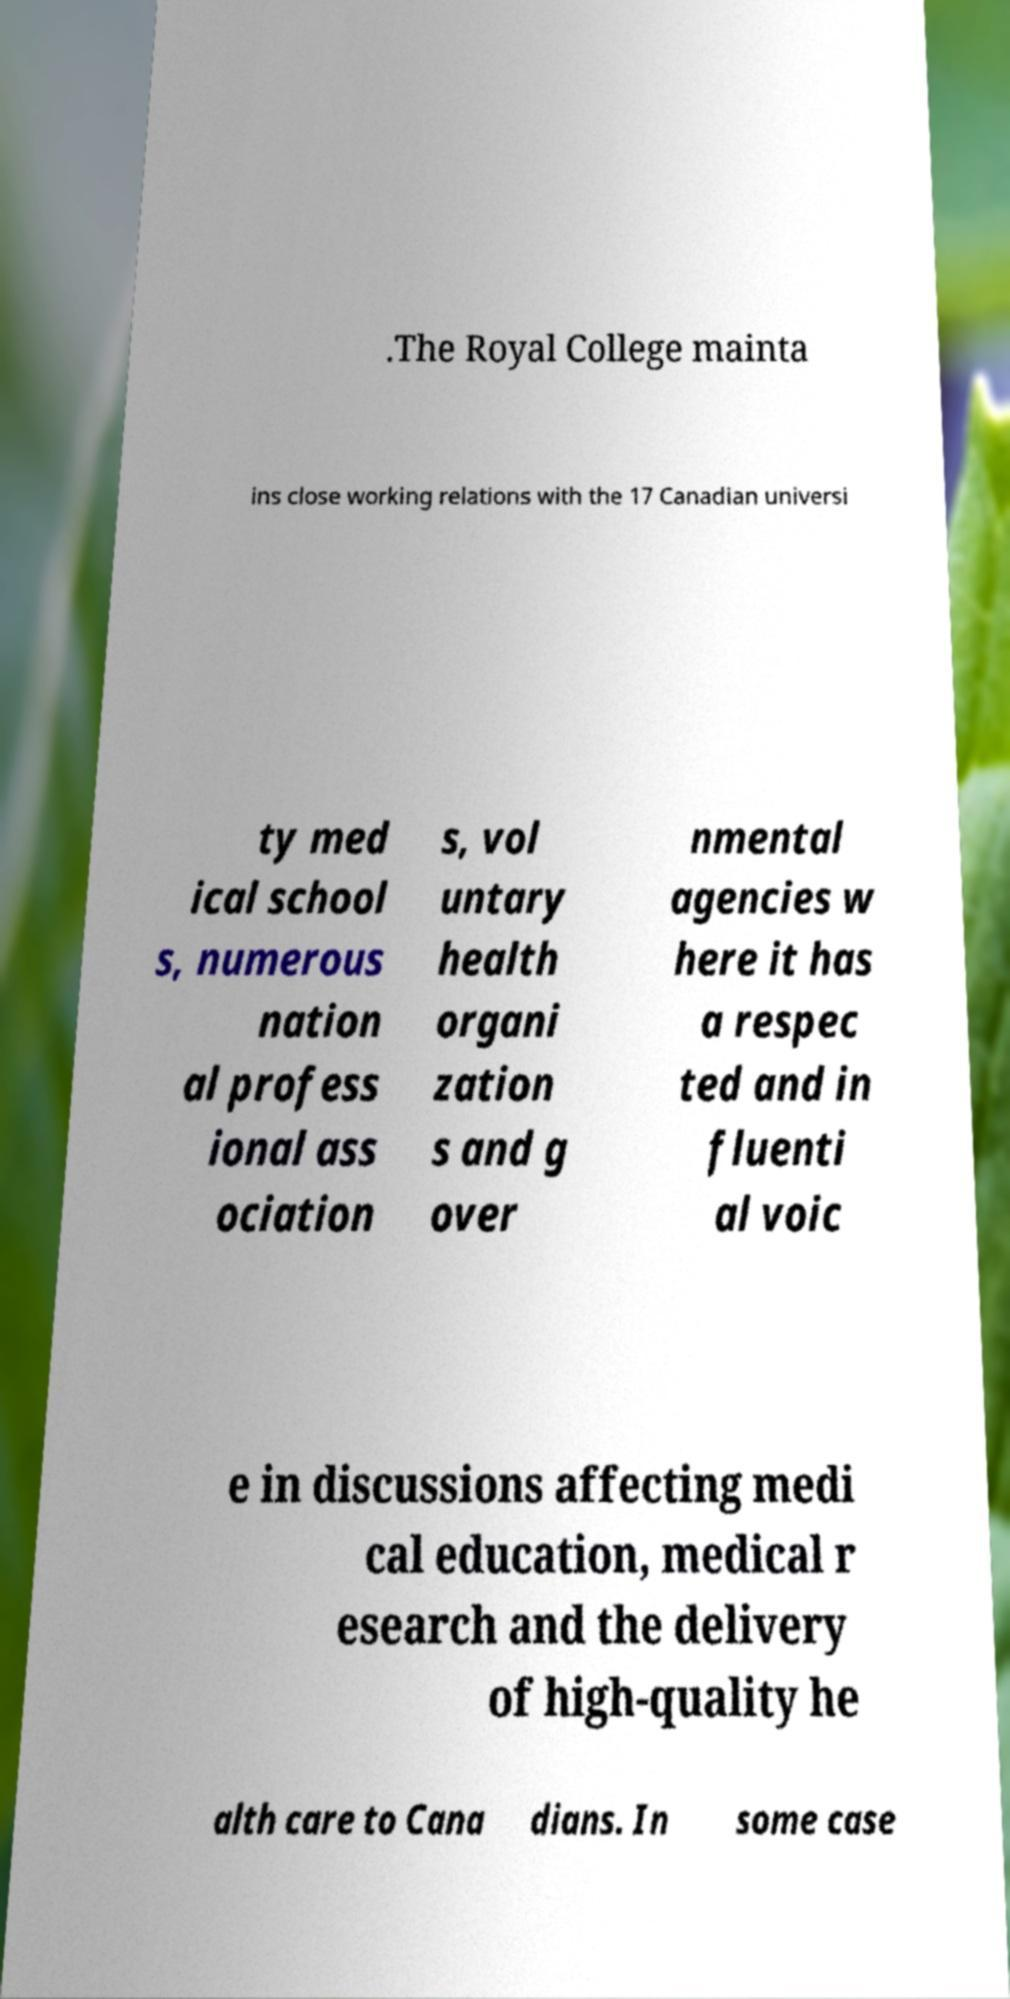There's text embedded in this image that I need extracted. Can you transcribe it verbatim? .The Royal College mainta ins close working relations with the 17 Canadian universi ty med ical school s, numerous nation al profess ional ass ociation s, vol untary health organi zation s and g over nmental agencies w here it has a respec ted and in fluenti al voic e in discussions affecting medi cal education, medical r esearch and the delivery of high-quality he alth care to Cana dians. In some case 